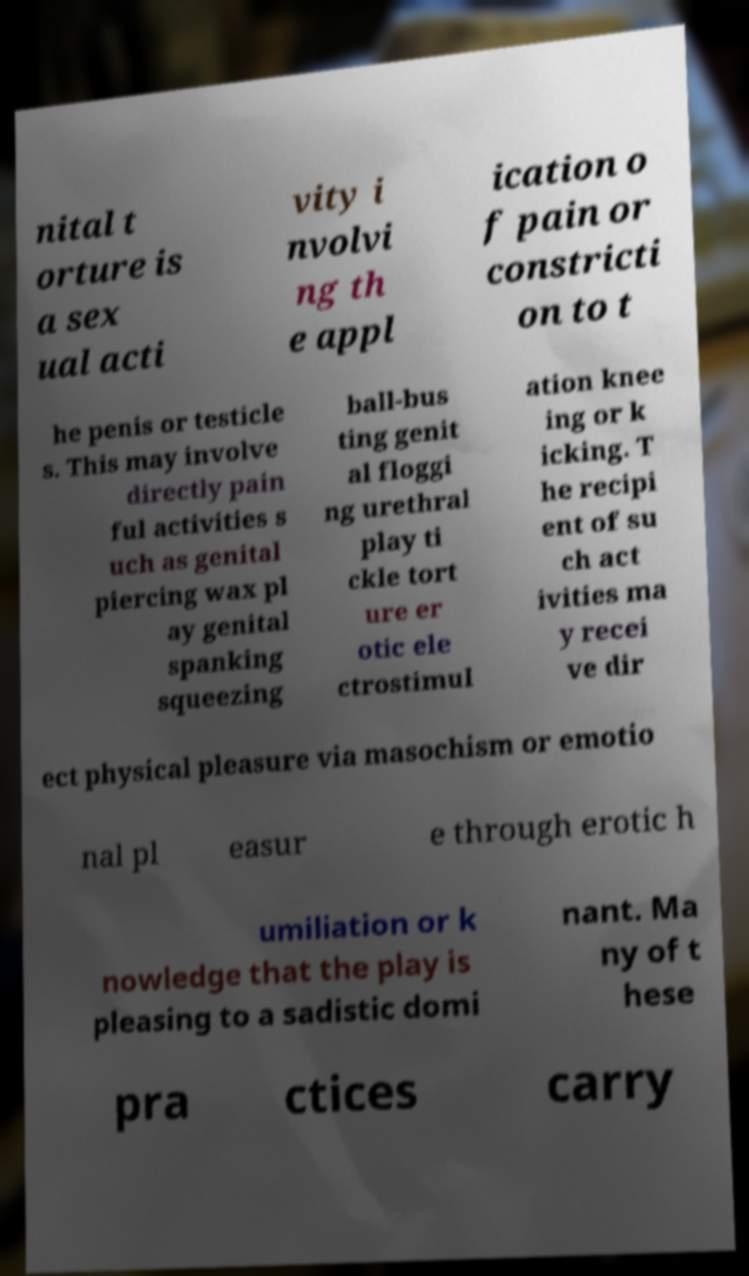Could you extract and type out the text from this image? nital t orture is a sex ual acti vity i nvolvi ng th e appl ication o f pain or constricti on to t he penis or testicle s. This may involve directly pain ful activities s uch as genital piercing wax pl ay genital spanking squeezing ball-bus ting genit al floggi ng urethral play ti ckle tort ure er otic ele ctrostimul ation knee ing or k icking. T he recipi ent of su ch act ivities ma y recei ve dir ect physical pleasure via masochism or emotio nal pl easur e through erotic h umiliation or k nowledge that the play is pleasing to a sadistic domi nant. Ma ny of t hese pra ctices carry 